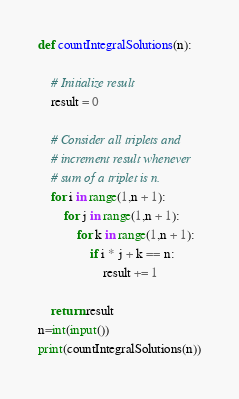<code> <loc_0><loc_0><loc_500><loc_500><_Python_>def countIntegralSolutions(n): 
  
    # Initialize result 
    result = 0
      
    # Consider all triplets and  
    # increment result whenever  
    # sum of a triplet is n. 
    for i in range(1,n + 1): 
        for j in range(1,n + 1): 
            for k in range(1,n + 1): 
                if i * j + k == n: 
                    result += 1
      
    return result
n=int(input())
print(countIntegralSolutions(n))</code> 